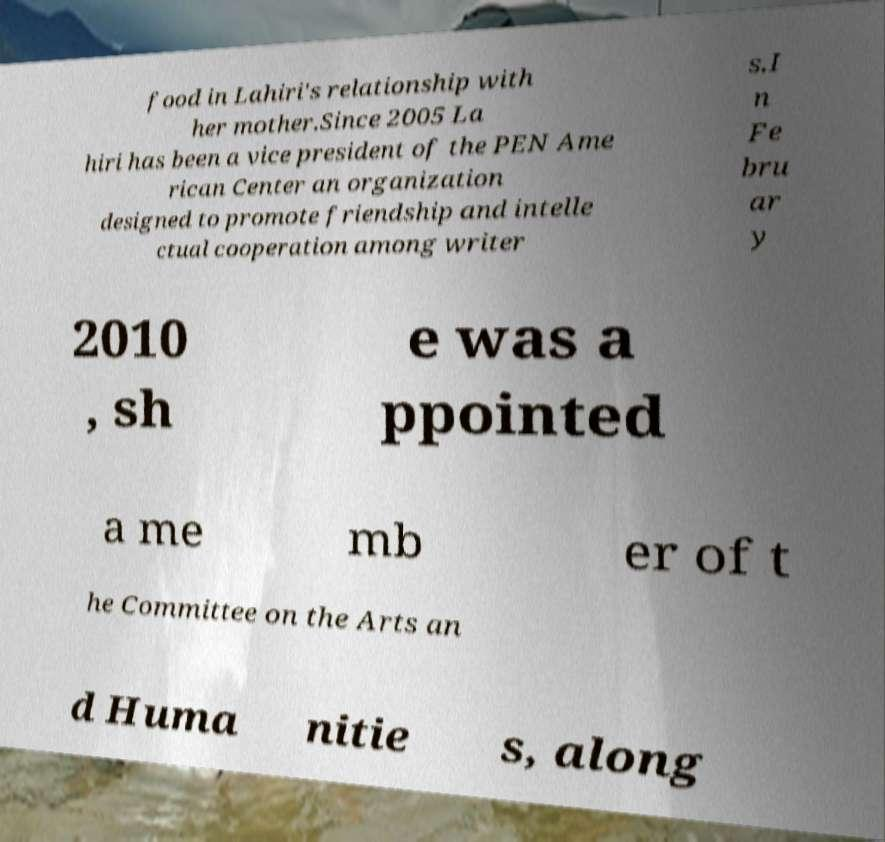For documentation purposes, I need the text within this image transcribed. Could you provide that? food in Lahiri's relationship with her mother.Since 2005 La hiri has been a vice president of the PEN Ame rican Center an organization designed to promote friendship and intelle ctual cooperation among writer s.I n Fe bru ar y 2010 , sh e was a ppointed a me mb er of t he Committee on the Arts an d Huma nitie s, along 